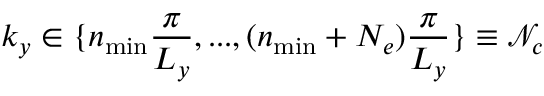Convert formula to latex. <formula><loc_0><loc_0><loc_500><loc_500>k _ { y } \in \{ n _ { \min } \frac { \pi } { L _ { y } } , \dots , ( n _ { \min } + N _ { e } ) \frac { \pi } { L _ { y } } \} \equiv \mathcal { N } _ { c }</formula> 